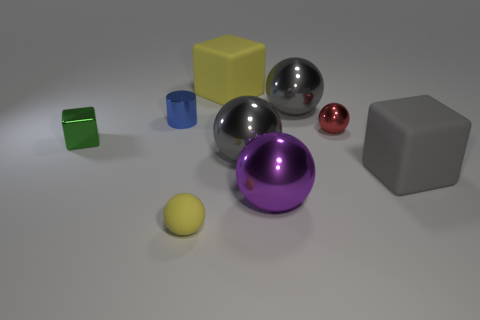Subtract all matte blocks. How many blocks are left? 1 Subtract all purple balls. How many balls are left? 4 Add 4 small spheres. How many small spheres are left? 6 Add 7 blue things. How many blue things exist? 8 Subtract 1 yellow spheres. How many objects are left? 8 Subtract all cubes. How many objects are left? 6 Subtract all purple blocks. Subtract all yellow spheres. How many blocks are left? 3 Subtract all cyan cubes. How many cyan spheres are left? 0 Subtract all large things. Subtract all cylinders. How many objects are left? 3 